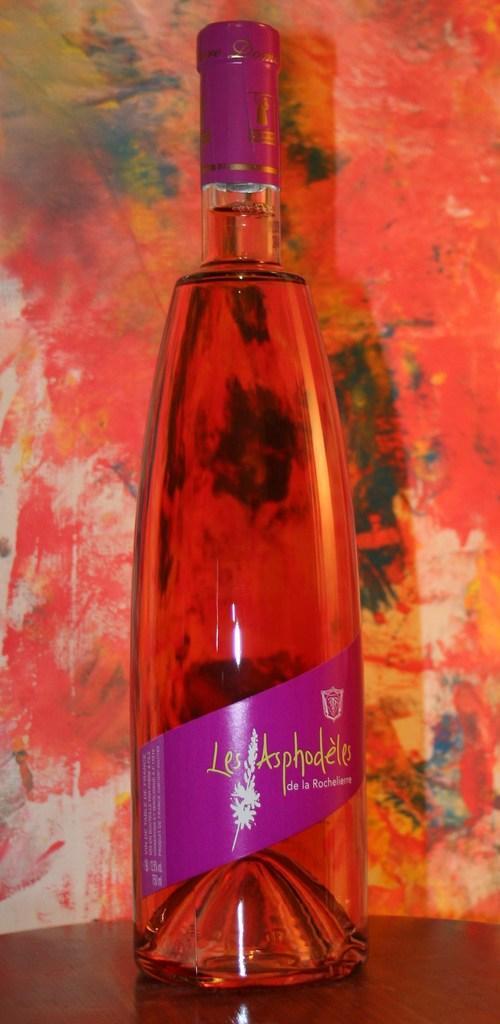Could you give a brief overview of what you see in this image? In this image i can see a bottle and at the background of the image there is a painting. 